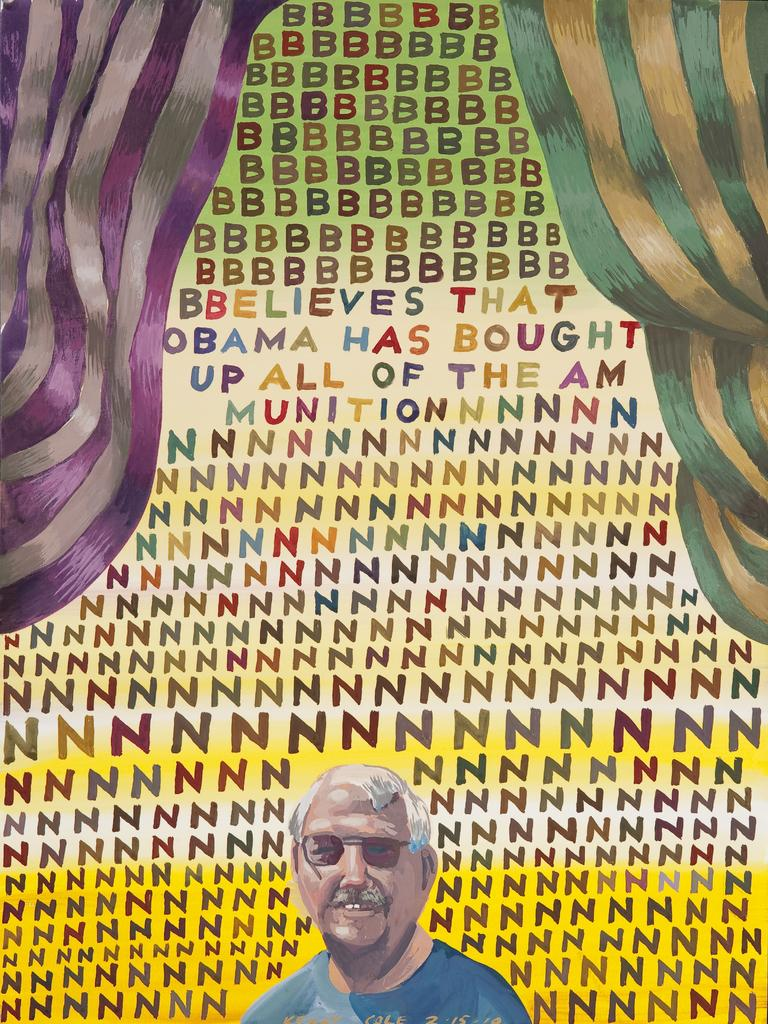Who or what is present in the image? There is a person in the image. What else can be seen in the image besides the person? There are alphabets and clothes in the image. What type of bread is being sold by the person in the image? There is no bread present in the image; it only features a person, alphabets, and clothes. Can you see any jellyfish in the image? There are no jellyfish present in the image. 